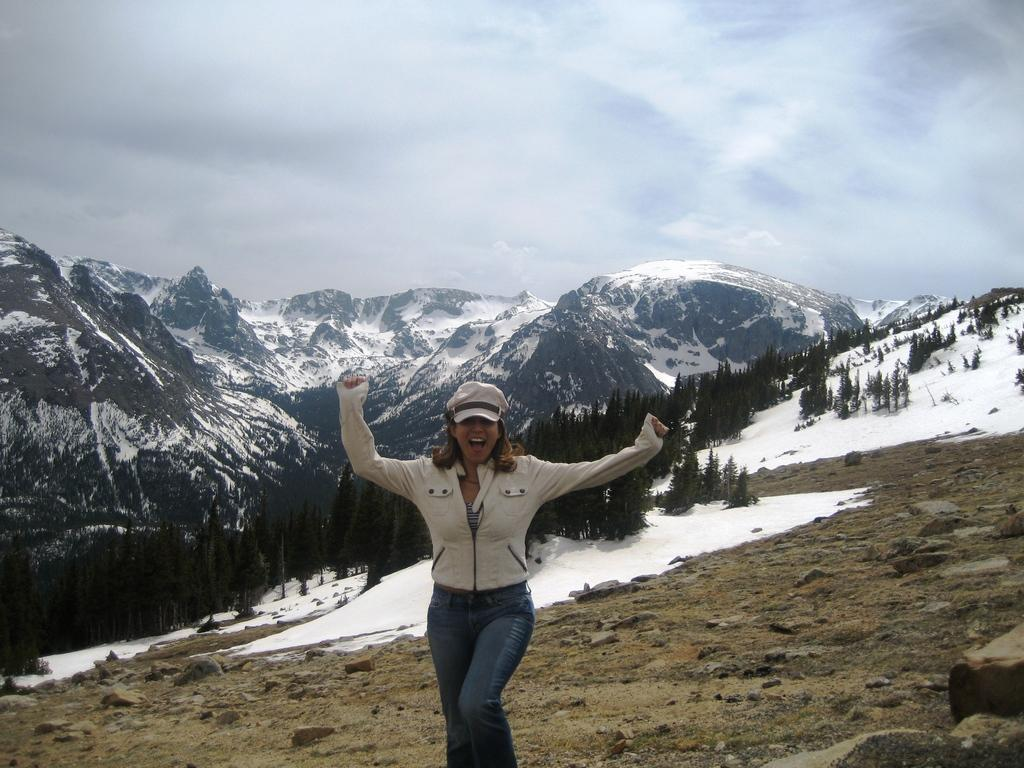What type of natural landscape can be seen in the image? There are mountains, trees, and grass visible in the image. What weather condition is present in the image? There is fog and clouds in the sky in the image. Is there any human presence in the image? Yes, there is a woman in the image. What type of grain can be seen growing in the image? There is no grain visible in the image; it features mountains, trees, grass, fog, clouds, and a woman. What time of day is depicted in the image? The time of day cannot be determined from the image, as there are no specific indicators of time. 